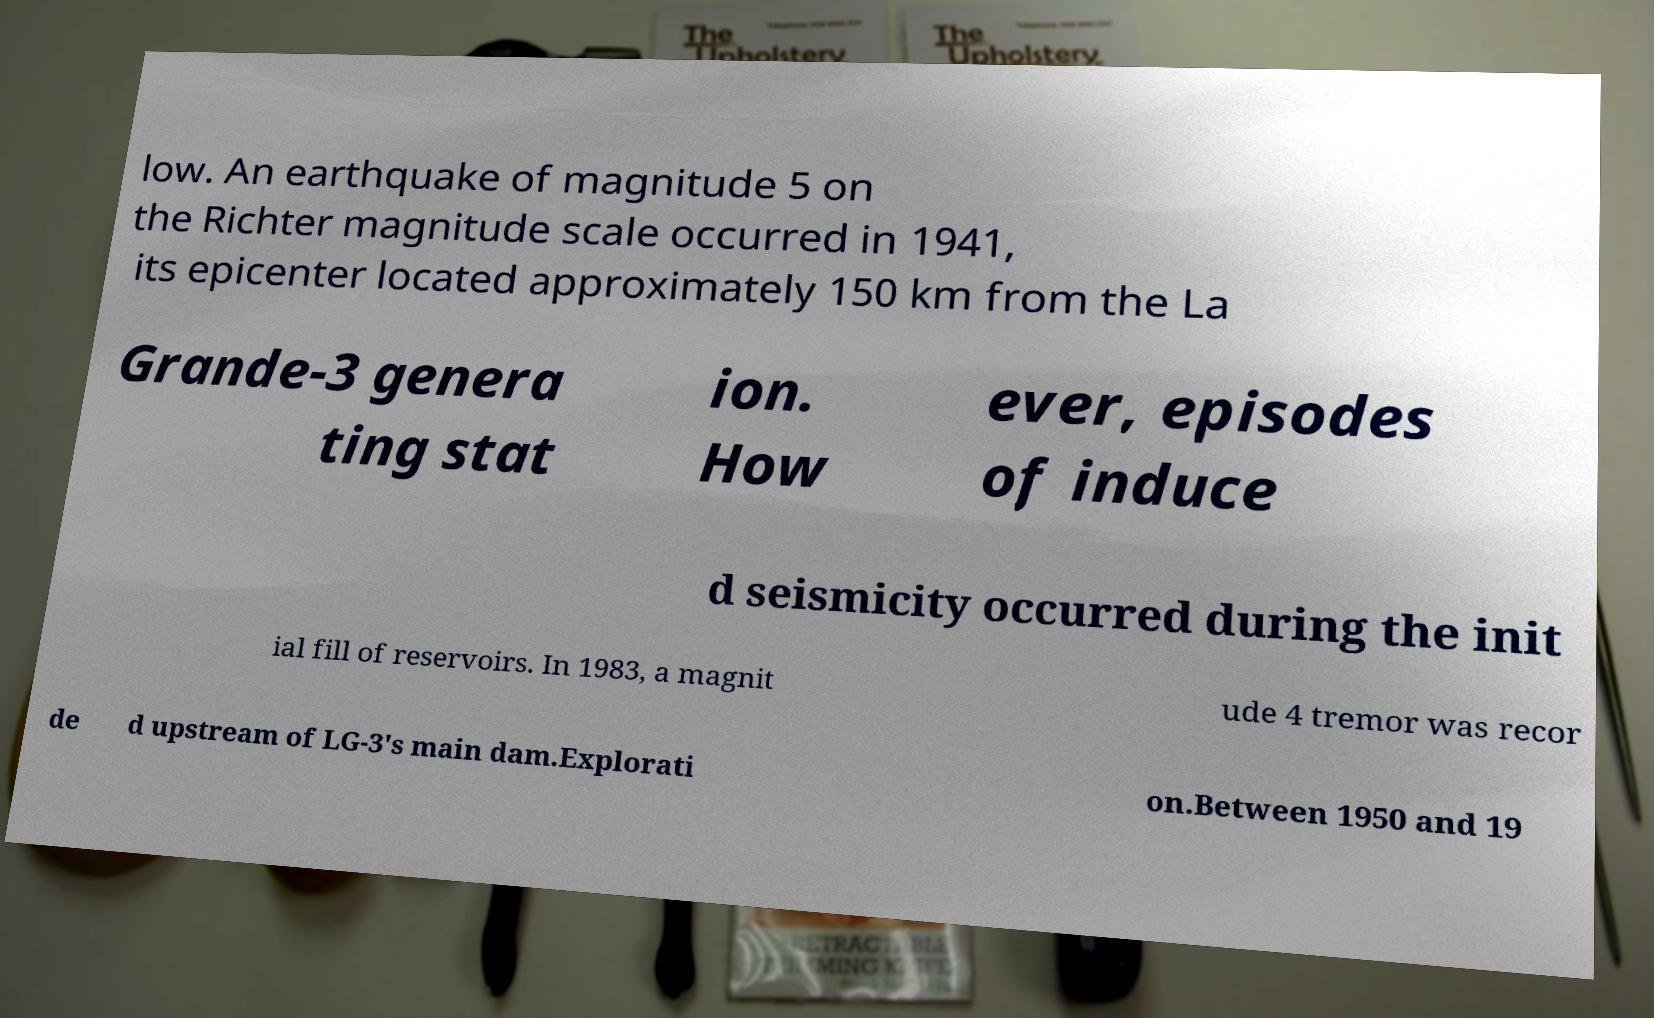Please identify and transcribe the text found in this image. low. An earthquake of magnitude 5 on the Richter magnitude scale occurred in 1941, its epicenter located approximately 150 km from the La Grande-3 genera ting stat ion. How ever, episodes of induce d seismicity occurred during the init ial fill of reservoirs. In 1983, a magnit ude 4 tremor was recor de d upstream of LG-3's main dam.Explorati on.Between 1950 and 19 